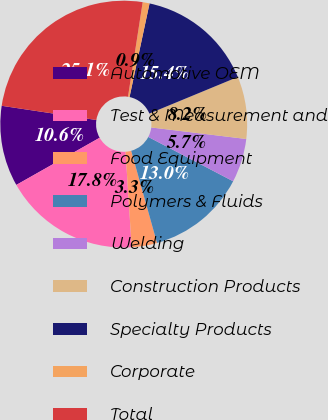<chart> <loc_0><loc_0><loc_500><loc_500><pie_chart><fcel>Automotive OEM<fcel>Test & Measurement and<fcel>Food Equipment<fcel>Polymers & Fluids<fcel>Welding<fcel>Construction Products<fcel>Specialty Products<fcel>Corporate<fcel>Total<nl><fcel>10.57%<fcel>17.83%<fcel>3.32%<fcel>12.99%<fcel>5.74%<fcel>8.16%<fcel>15.41%<fcel>0.9%<fcel>25.08%<nl></chart> 